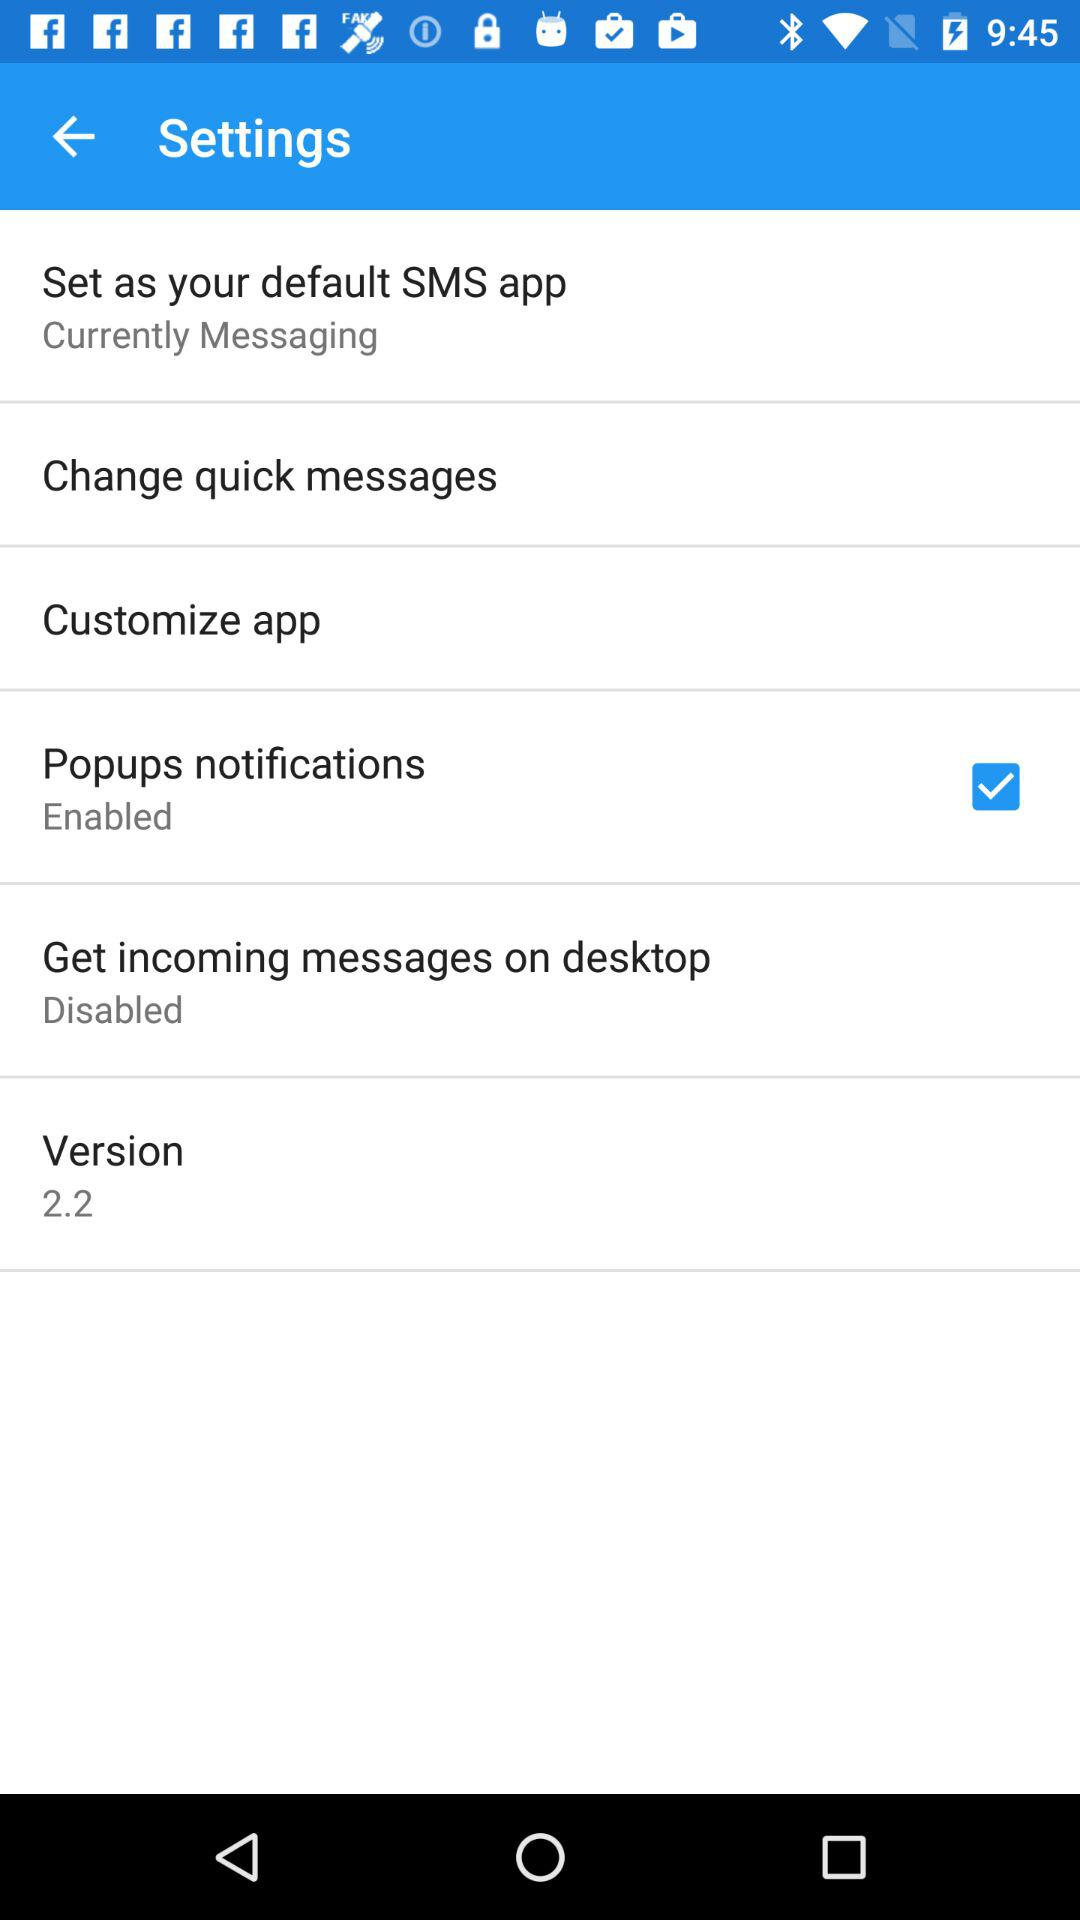What is the status of "Popups notifications"? "Popups notifications" is enabled. 